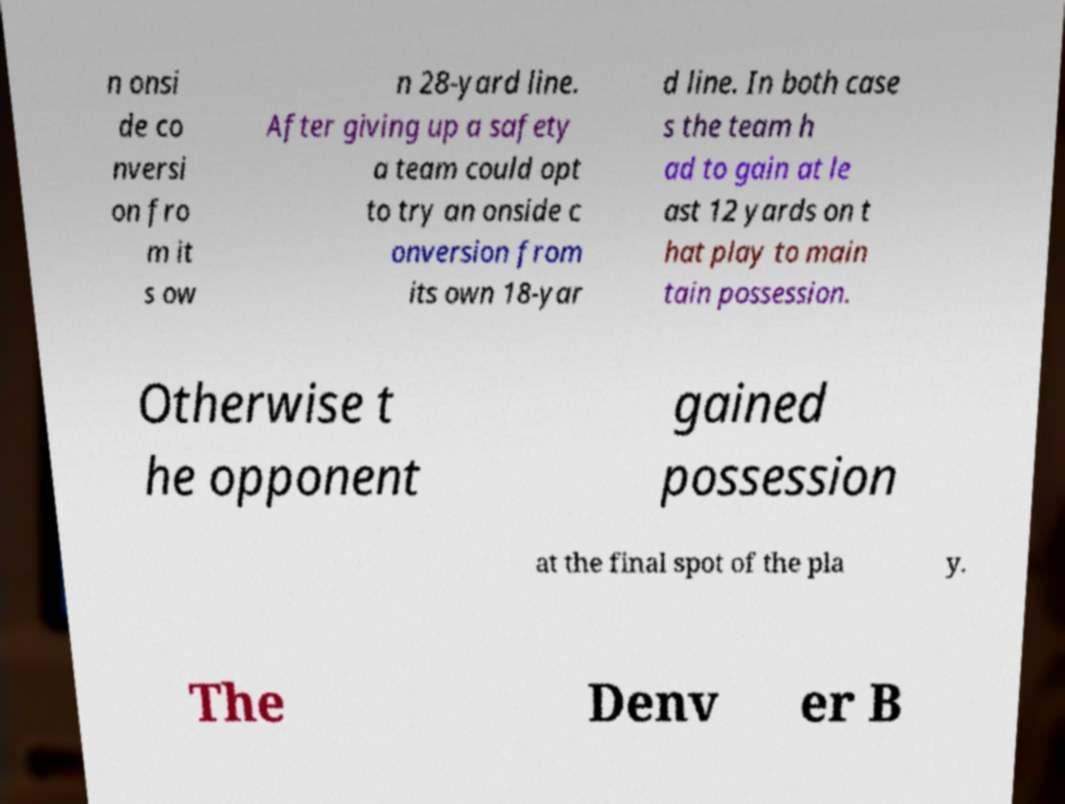Can you accurately transcribe the text from the provided image for me? n onsi de co nversi on fro m it s ow n 28-yard line. After giving up a safety a team could opt to try an onside c onversion from its own 18-yar d line. In both case s the team h ad to gain at le ast 12 yards on t hat play to main tain possession. Otherwise t he opponent gained possession at the final spot of the pla y. The Denv er B 